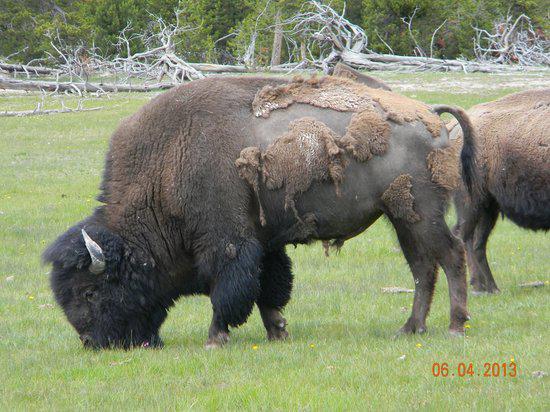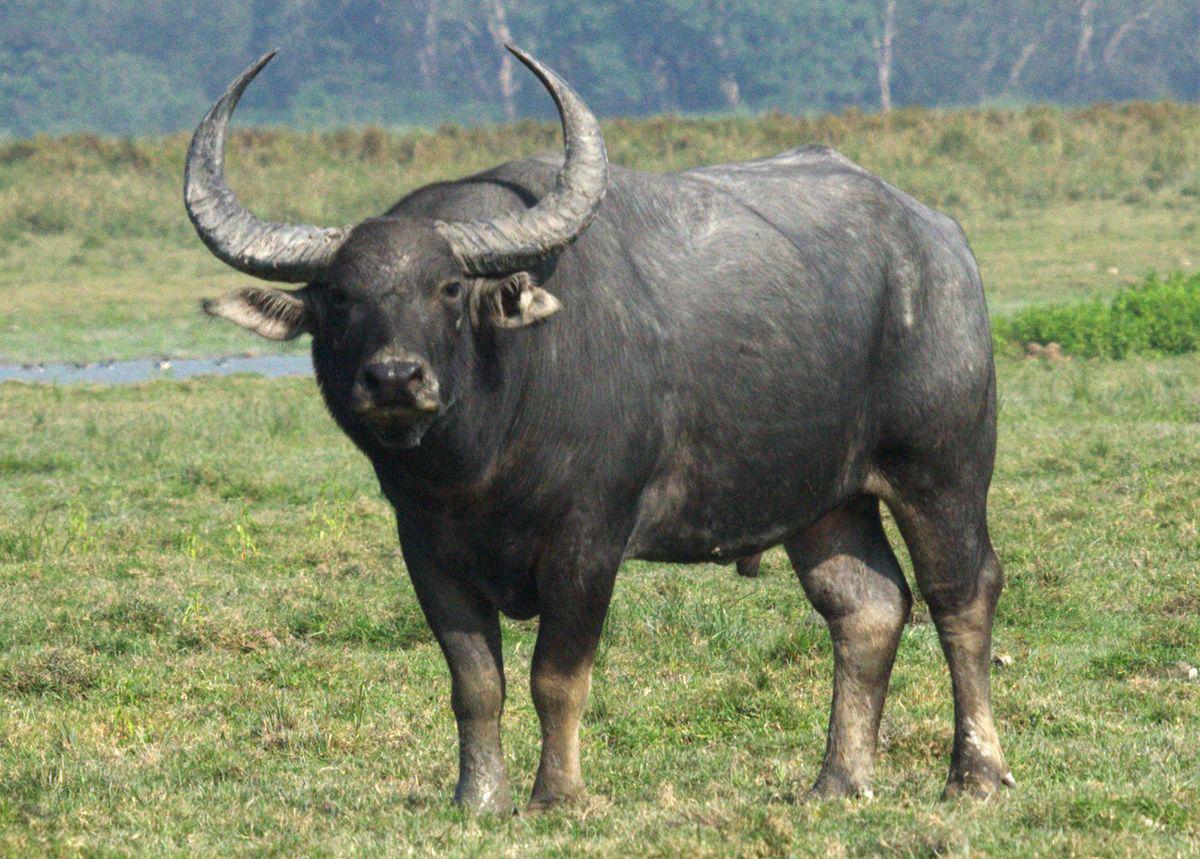The first image is the image on the left, the second image is the image on the right. Analyze the images presented: Is the assertion "There are at least five water buffalo." valid? Answer yes or no. No. The first image is the image on the left, the second image is the image on the right. Examine the images to the left and right. Is the description "One of the images contains an animal that is not a water buffalo." accurate? Answer yes or no. Yes. The first image is the image on the left, the second image is the image on the right. For the images shown, is this caption "The image on the left contains only one water buffalo." true? Answer yes or no. No. 